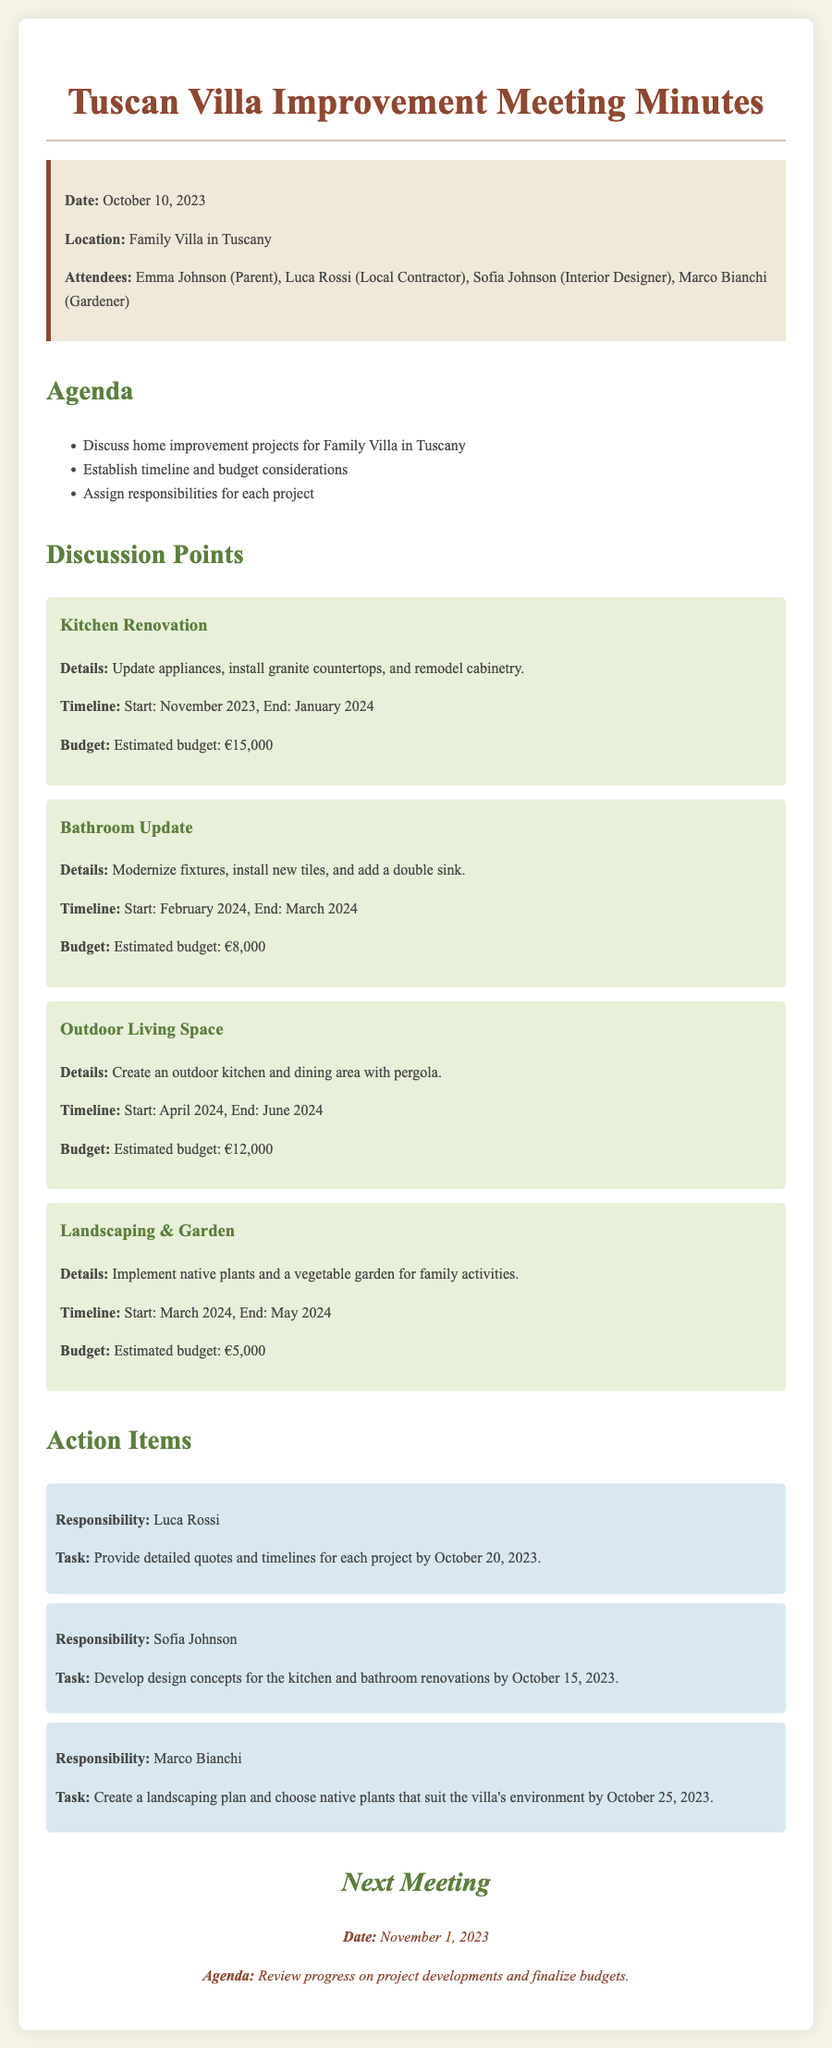What is the date of the meeting? The date of the meeting is clearly stated in the info box at the top of the document.
Answer: October 10, 2023 Who is the local contractor? The local contractor is one of the attendees listed in the document.
Answer: Luca Rossi What is the estimated budget for the kitchen renovation? The estimated budget for the kitchen renovation is detailed in the project section of the document.
Answer: €15,000 When is the landscaping project scheduled to start? The start date for the landscaping project is specified in the timeline of that project.
Answer: March 2024 What is Marco Bianchi responsible for? Marco Bianchi's responsibility is outlined in the action items section of the document.
Answer: Create a landscaping plan What is the end date for the outdoor living space project? The end date is found in the project details for outdoor living space.
Answer: June 2024 How much is the estimated budget for the bathroom update? The budget is provided in the bathroom update project's details.
Answer: €8,000 When is the next meeting scheduled? The date for the next meeting is mentioned at the end of the document.
Answer: November 1, 2023 What design concepts is Sofia Johnson tasked with developing? Sofia Johnson's task is specified in the action items section.
Answer: Kitchen and bathroom renovations 